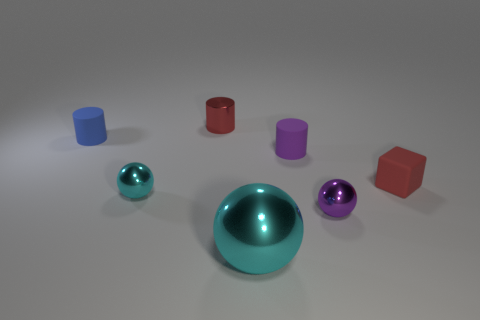Add 2 small blocks. How many objects exist? 9 Subtract all cylinders. How many objects are left? 4 Add 5 small green shiny cylinders. How many small green shiny cylinders exist? 5 Subtract 0 gray blocks. How many objects are left? 7 Subtract all tiny matte things. Subtract all blue things. How many objects are left? 3 Add 3 metal balls. How many metal balls are left? 6 